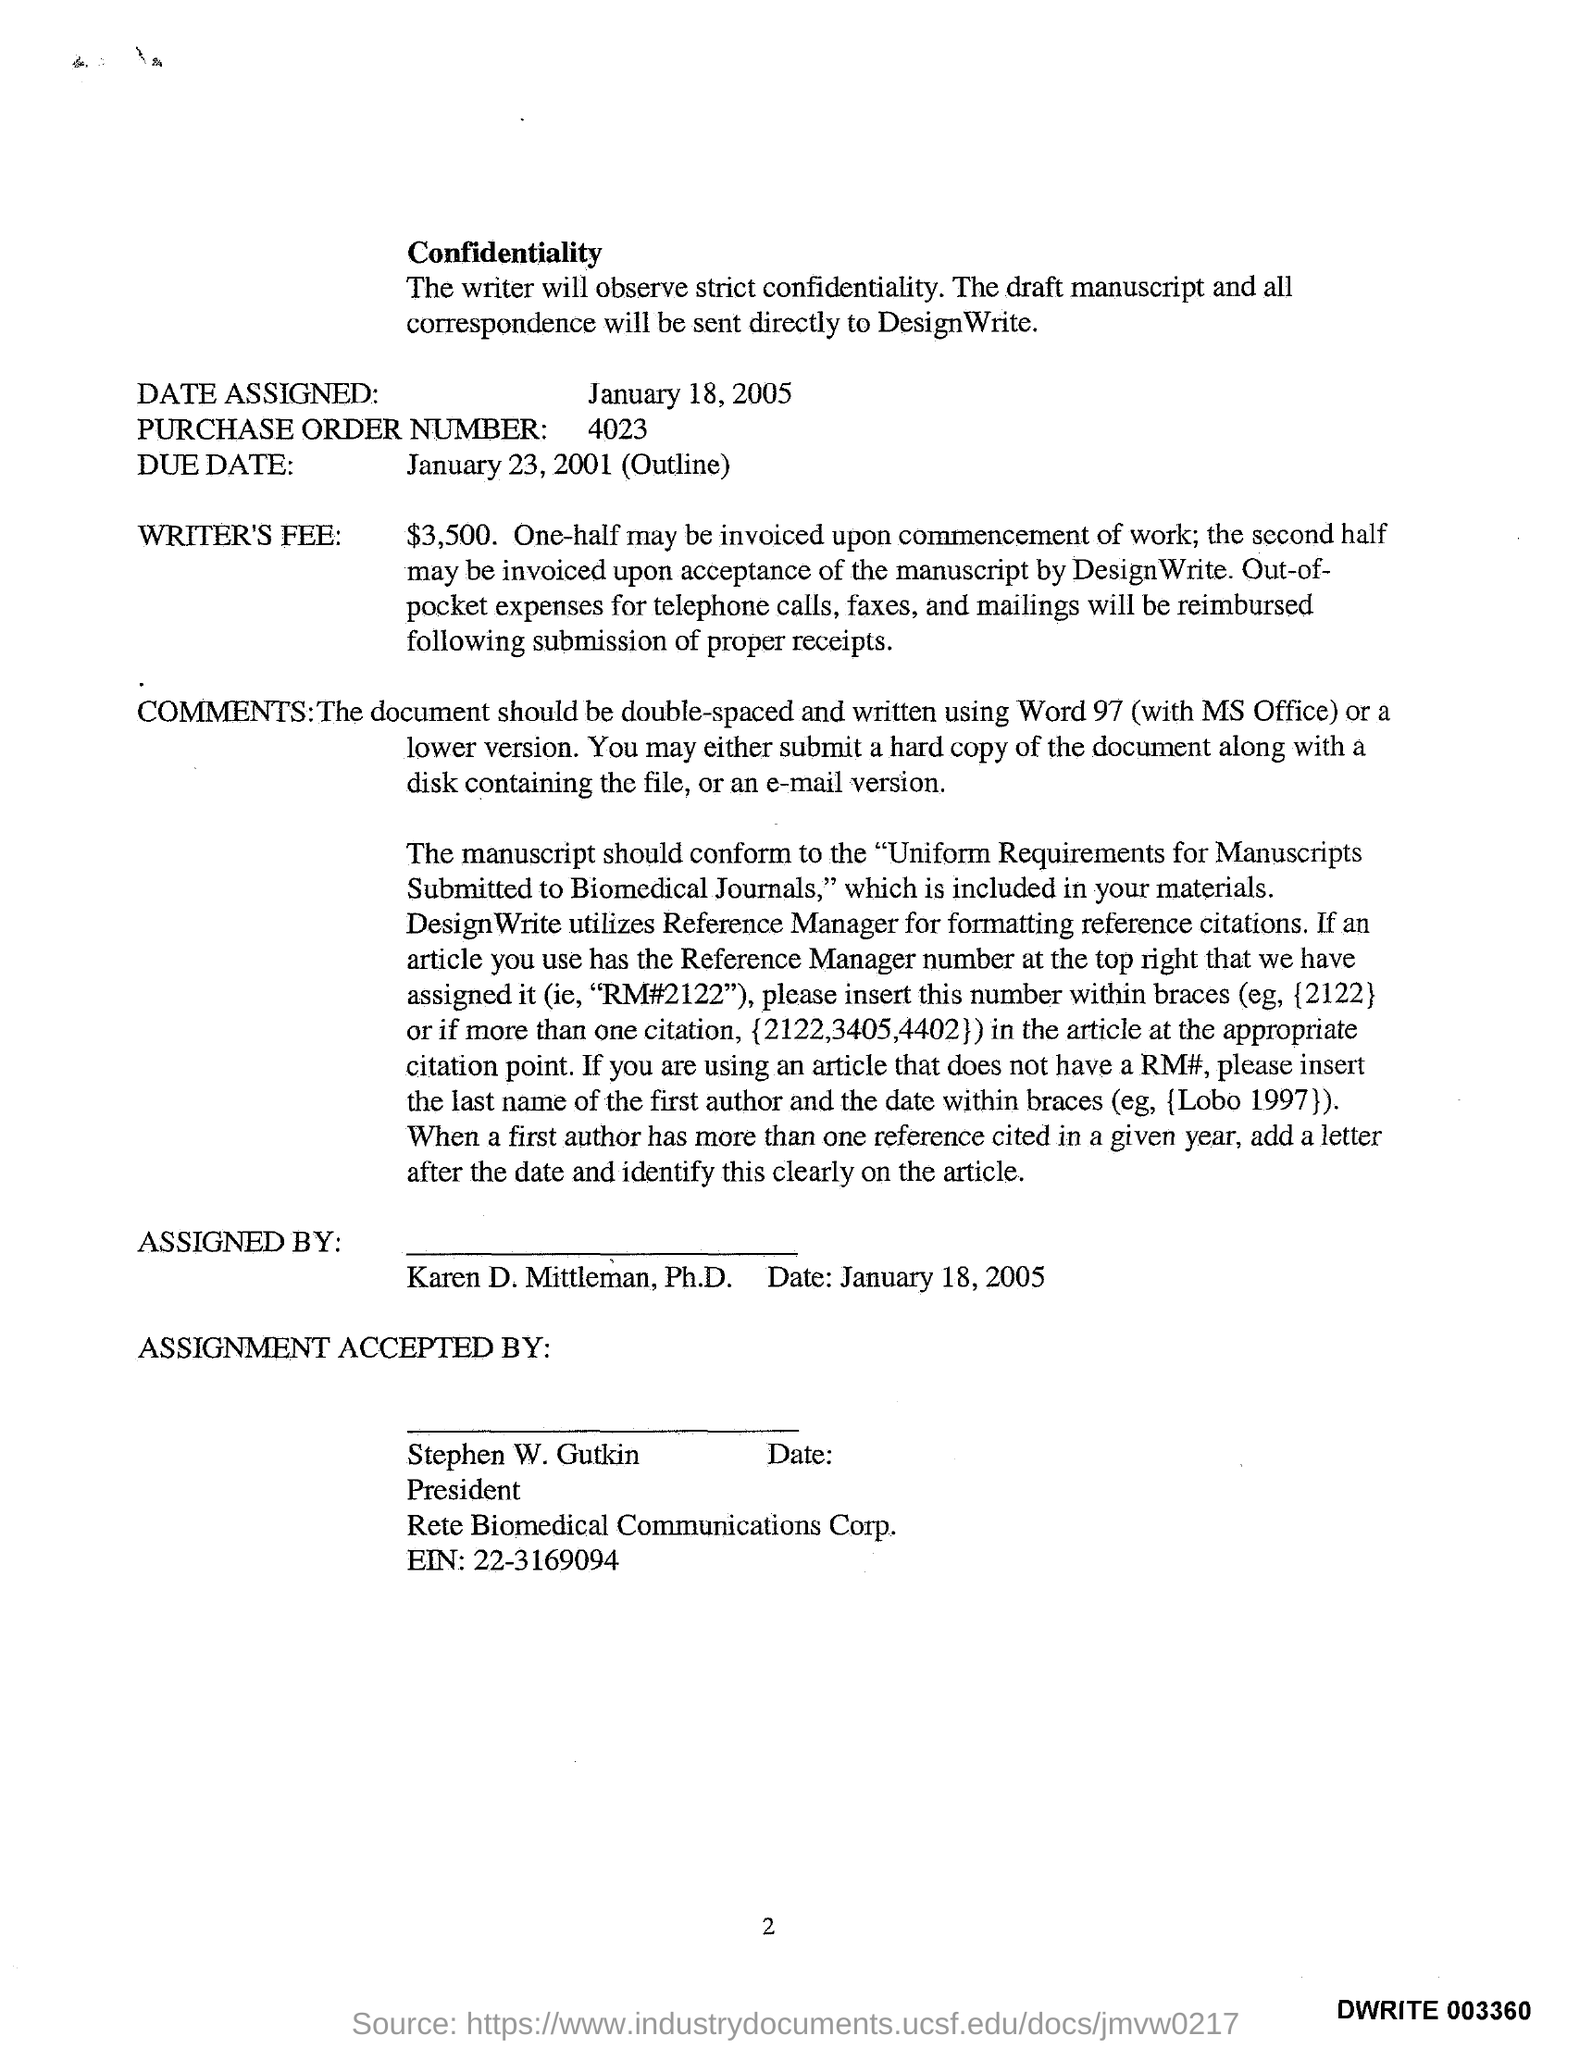What is the Purchase Order Number?
Make the answer very short. 4023. 